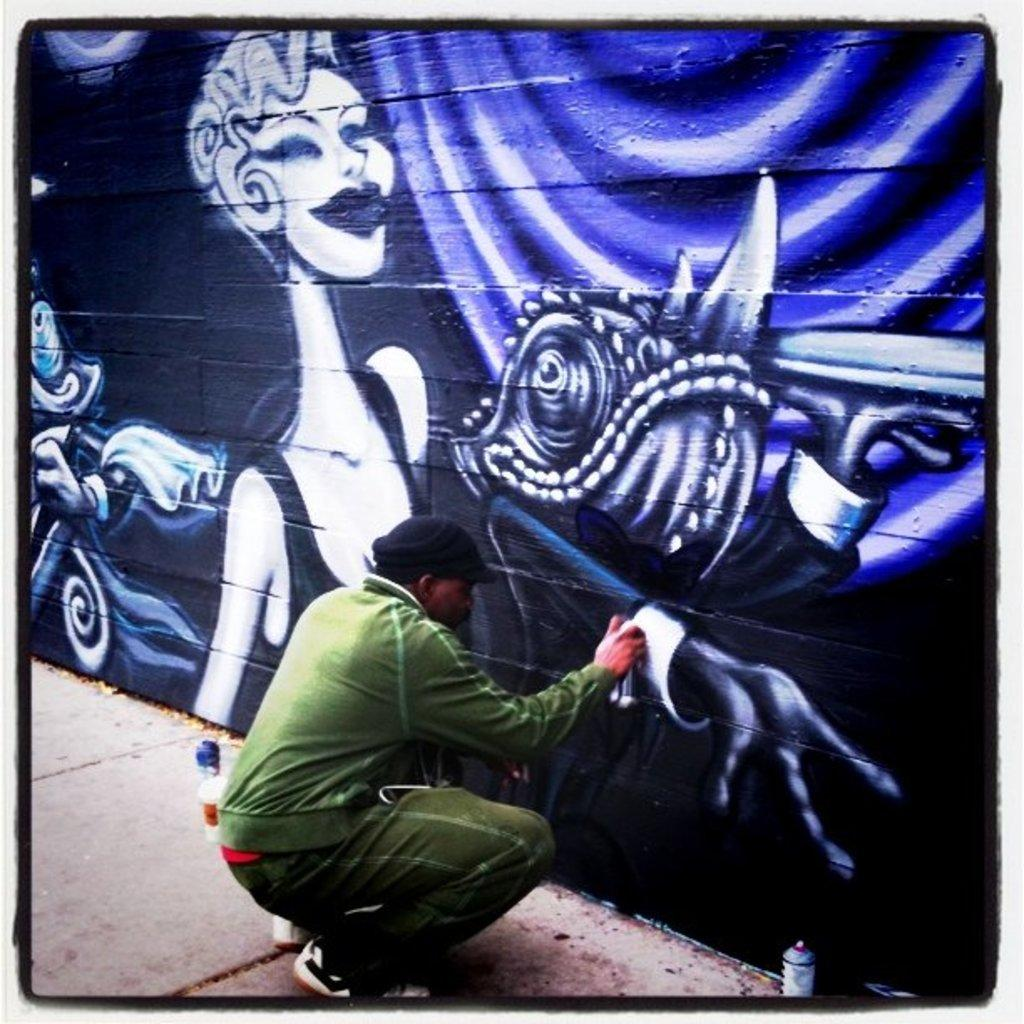What is the person in the image holding? The person is holding a bottle in the image. Are there any other bottles visible in the image? Yes, there are other bottles on the road in the image. What can be seen on the wall in the background of the image? There is graffiti on a wall in the background of the image. What type of representative is present in the image? There is no representative present in the image; it features a person holding a bottle, other bottles on the road, and graffiti on a wall. What market is depicted in the image? There is no market depicted in the image. 